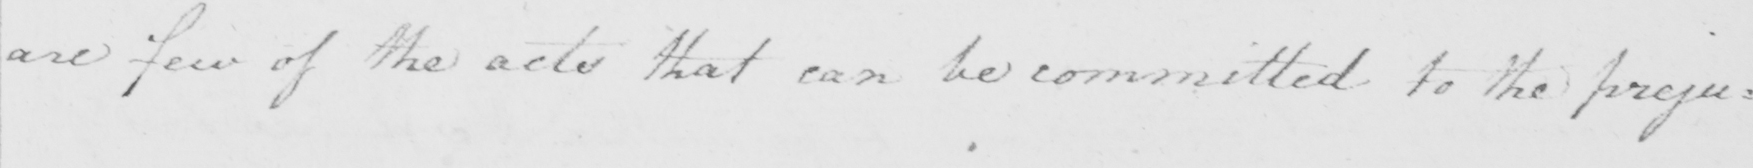Transcribe the text shown in this historical manuscript line. are few of the acts that can be committed to the preju= 